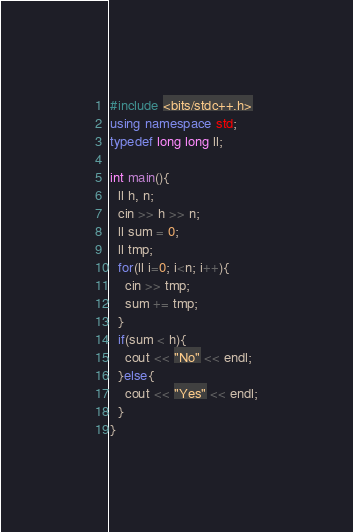Convert code to text. <code><loc_0><loc_0><loc_500><loc_500><_C++_>#include <bits/stdc++.h>
using namespace std;
typedef long long ll;

int main(){
  ll h, n;
  cin >> h >> n;
  ll sum = 0;
  ll tmp;
  for(ll i=0; i<n; i++){
  	cin >> tmp;
    sum += tmp;
  }
  if(sum < h){
  	cout << "No" << endl;
  }else{
  	cout << "Yes" << endl;
  }
}</code> 